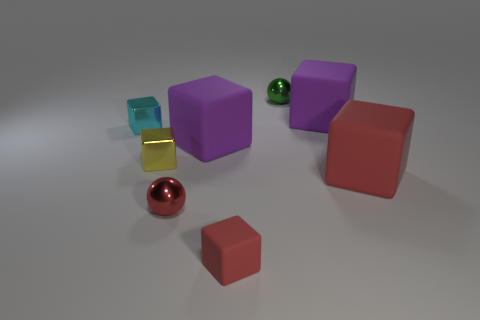Subtract all purple blocks. How many blocks are left? 4 Subtract all spheres. How many objects are left? 6 Subtract 2 spheres. How many spheres are left? 0 Subtract all brown spheres. Subtract all purple cubes. How many spheres are left? 2 Subtract all cyan spheres. How many brown cubes are left? 0 Subtract all purple metal objects. Subtract all tiny yellow shiny things. How many objects are left? 7 Add 6 large purple matte objects. How many large purple matte objects are left? 8 Add 2 big red rubber objects. How many big red rubber objects exist? 3 Add 1 tiny cyan metal objects. How many objects exist? 9 Subtract all small metallic blocks. How many blocks are left? 4 